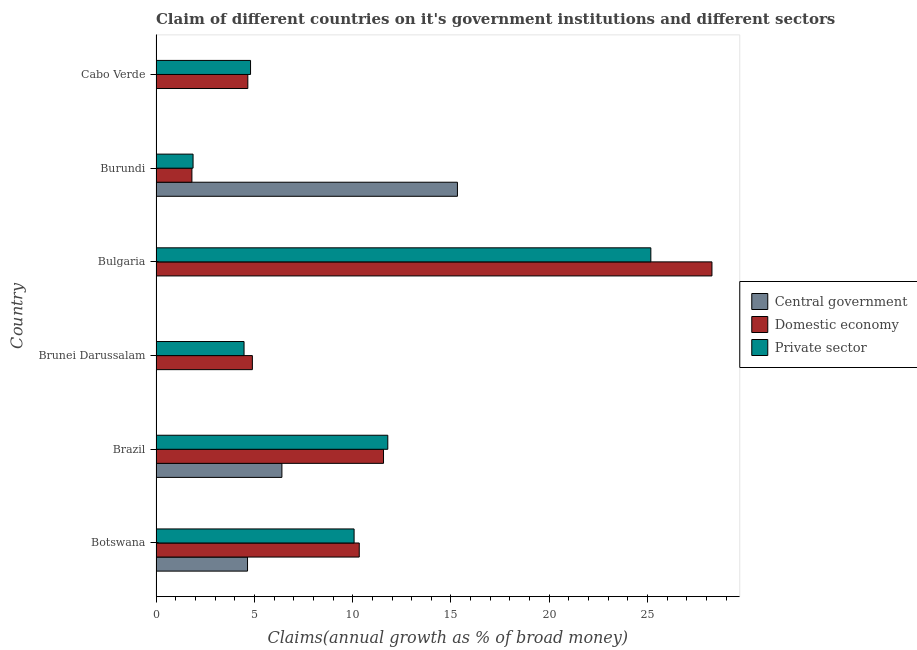Are the number of bars per tick equal to the number of legend labels?
Your answer should be compact. No. Are the number of bars on each tick of the Y-axis equal?
Give a very brief answer. No. How many bars are there on the 3rd tick from the bottom?
Offer a very short reply. 2. What is the label of the 2nd group of bars from the top?
Provide a succinct answer. Burundi. Across all countries, what is the maximum percentage of claim on the private sector?
Give a very brief answer. 25.16. Across all countries, what is the minimum percentage of claim on the private sector?
Your answer should be very brief. 1.88. In which country was the percentage of claim on the central government maximum?
Ensure brevity in your answer.  Burundi. What is the total percentage of claim on the central government in the graph?
Provide a succinct answer. 26.38. What is the difference between the percentage of claim on the domestic economy in Brunei Darussalam and that in Bulgaria?
Provide a short and direct response. -23.37. What is the difference between the percentage of claim on the private sector in Bulgaria and the percentage of claim on the central government in Cabo Verde?
Offer a very short reply. 25.16. What is the average percentage of claim on the central government per country?
Ensure brevity in your answer.  4.4. What is the difference between the percentage of claim on the domestic economy and percentage of claim on the private sector in Brazil?
Your answer should be compact. -0.22. What is the ratio of the percentage of claim on the domestic economy in Botswana to that in Cabo Verde?
Your response must be concise. 2.21. What is the difference between the highest and the second highest percentage of claim on the domestic economy?
Your answer should be compact. 16.7. What is the difference between the highest and the lowest percentage of claim on the private sector?
Keep it short and to the point. 23.28. In how many countries, is the percentage of claim on the private sector greater than the average percentage of claim on the private sector taken over all countries?
Offer a terse response. 3. Is the sum of the percentage of claim on the central government in Botswana and Burundi greater than the maximum percentage of claim on the domestic economy across all countries?
Keep it short and to the point. No. Are all the bars in the graph horizontal?
Make the answer very short. Yes. Are the values on the major ticks of X-axis written in scientific E-notation?
Your answer should be compact. No. Does the graph contain grids?
Offer a terse response. No. What is the title of the graph?
Keep it short and to the point. Claim of different countries on it's government institutions and different sectors. Does "Transport equipments" appear as one of the legend labels in the graph?
Your response must be concise. No. What is the label or title of the X-axis?
Give a very brief answer. Claims(annual growth as % of broad money). What is the label or title of the Y-axis?
Offer a terse response. Country. What is the Claims(annual growth as % of broad money) in Central government in Botswana?
Your response must be concise. 4.65. What is the Claims(annual growth as % of broad money) of Domestic economy in Botswana?
Your response must be concise. 10.33. What is the Claims(annual growth as % of broad money) in Private sector in Botswana?
Your answer should be compact. 10.07. What is the Claims(annual growth as % of broad money) of Central government in Brazil?
Offer a terse response. 6.4. What is the Claims(annual growth as % of broad money) in Domestic economy in Brazil?
Your answer should be compact. 11.57. What is the Claims(annual growth as % of broad money) in Private sector in Brazil?
Provide a succinct answer. 11.79. What is the Claims(annual growth as % of broad money) in Domestic economy in Brunei Darussalam?
Keep it short and to the point. 4.9. What is the Claims(annual growth as % of broad money) in Private sector in Brunei Darussalam?
Your answer should be very brief. 4.48. What is the Claims(annual growth as % of broad money) of Domestic economy in Bulgaria?
Offer a very short reply. 28.27. What is the Claims(annual growth as % of broad money) of Private sector in Bulgaria?
Offer a very short reply. 25.16. What is the Claims(annual growth as % of broad money) of Central government in Burundi?
Your answer should be compact. 15.33. What is the Claims(annual growth as % of broad money) in Domestic economy in Burundi?
Ensure brevity in your answer.  1.83. What is the Claims(annual growth as % of broad money) of Private sector in Burundi?
Provide a short and direct response. 1.88. What is the Claims(annual growth as % of broad money) of Domestic economy in Cabo Verde?
Your answer should be very brief. 4.67. What is the Claims(annual growth as % of broad money) in Private sector in Cabo Verde?
Keep it short and to the point. 4.81. Across all countries, what is the maximum Claims(annual growth as % of broad money) in Central government?
Provide a short and direct response. 15.33. Across all countries, what is the maximum Claims(annual growth as % of broad money) in Domestic economy?
Provide a succinct answer. 28.27. Across all countries, what is the maximum Claims(annual growth as % of broad money) in Private sector?
Ensure brevity in your answer.  25.16. Across all countries, what is the minimum Claims(annual growth as % of broad money) of Central government?
Make the answer very short. 0. Across all countries, what is the minimum Claims(annual growth as % of broad money) of Domestic economy?
Keep it short and to the point. 1.83. Across all countries, what is the minimum Claims(annual growth as % of broad money) of Private sector?
Provide a short and direct response. 1.88. What is the total Claims(annual growth as % of broad money) of Central government in the graph?
Ensure brevity in your answer.  26.38. What is the total Claims(annual growth as % of broad money) in Domestic economy in the graph?
Make the answer very short. 61.57. What is the total Claims(annual growth as % of broad money) in Private sector in the graph?
Your answer should be very brief. 58.19. What is the difference between the Claims(annual growth as % of broad money) of Central government in Botswana and that in Brazil?
Your response must be concise. -1.75. What is the difference between the Claims(annual growth as % of broad money) in Domestic economy in Botswana and that in Brazil?
Make the answer very short. -1.23. What is the difference between the Claims(annual growth as % of broad money) in Private sector in Botswana and that in Brazil?
Your answer should be very brief. -1.71. What is the difference between the Claims(annual growth as % of broad money) of Domestic economy in Botswana and that in Brunei Darussalam?
Offer a terse response. 5.43. What is the difference between the Claims(annual growth as % of broad money) of Private sector in Botswana and that in Brunei Darussalam?
Your answer should be compact. 5.6. What is the difference between the Claims(annual growth as % of broad money) in Domestic economy in Botswana and that in Bulgaria?
Offer a terse response. -17.94. What is the difference between the Claims(annual growth as % of broad money) of Private sector in Botswana and that in Bulgaria?
Provide a succinct answer. -15.09. What is the difference between the Claims(annual growth as % of broad money) of Central government in Botswana and that in Burundi?
Your answer should be very brief. -10.67. What is the difference between the Claims(annual growth as % of broad money) in Domestic economy in Botswana and that in Burundi?
Provide a succinct answer. 8.51. What is the difference between the Claims(annual growth as % of broad money) of Private sector in Botswana and that in Burundi?
Your answer should be compact. 8.19. What is the difference between the Claims(annual growth as % of broad money) in Domestic economy in Botswana and that in Cabo Verde?
Offer a very short reply. 5.67. What is the difference between the Claims(annual growth as % of broad money) in Private sector in Botswana and that in Cabo Verde?
Ensure brevity in your answer.  5.27. What is the difference between the Claims(annual growth as % of broad money) of Domestic economy in Brazil and that in Brunei Darussalam?
Provide a short and direct response. 6.67. What is the difference between the Claims(annual growth as % of broad money) of Private sector in Brazil and that in Brunei Darussalam?
Your answer should be compact. 7.31. What is the difference between the Claims(annual growth as % of broad money) in Domestic economy in Brazil and that in Bulgaria?
Provide a short and direct response. -16.7. What is the difference between the Claims(annual growth as % of broad money) in Private sector in Brazil and that in Bulgaria?
Ensure brevity in your answer.  -13.38. What is the difference between the Claims(annual growth as % of broad money) of Central government in Brazil and that in Burundi?
Your answer should be compact. -8.93. What is the difference between the Claims(annual growth as % of broad money) of Domestic economy in Brazil and that in Burundi?
Your answer should be very brief. 9.74. What is the difference between the Claims(annual growth as % of broad money) of Private sector in Brazil and that in Burundi?
Make the answer very short. 9.9. What is the difference between the Claims(annual growth as % of broad money) of Private sector in Brazil and that in Cabo Verde?
Your answer should be very brief. 6.98. What is the difference between the Claims(annual growth as % of broad money) of Domestic economy in Brunei Darussalam and that in Bulgaria?
Give a very brief answer. -23.37. What is the difference between the Claims(annual growth as % of broad money) in Private sector in Brunei Darussalam and that in Bulgaria?
Your answer should be compact. -20.69. What is the difference between the Claims(annual growth as % of broad money) in Domestic economy in Brunei Darussalam and that in Burundi?
Your response must be concise. 3.07. What is the difference between the Claims(annual growth as % of broad money) of Private sector in Brunei Darussalam and that in Burundi?
Your answer should be compact. 2.59. What is the difference between the Claims(annual growth as % of broad money) in Domestic economy in Brunei Darussalam and that in Cabo Verde?
Provide a succinct answer. 0.23. What is the difference between the Claims(annual growth as % of broad money) in Private sector in Brunei Darussalam and that in Cabo Verde?
Provide a short and direct response. -0.33. What is the difference between the Claims(annual growth as % of broad money) in Domestic economy in Bulgaria and that in Burundi?
Provide a short and direct response. 26.45. What is the difference between the Claims(annual growth as % of broad money) of Private sector in Bulgaria and that in Burundi?
Provide a short and direct response. 23.28. What is the difference between the Claims(annual growth as % of broad money) of Domestic economy in Bulgaria and that in Cabo Verde?
Offer a very short reply. 23.6. What is the difference between the Claims(annual growth as % of broad money) of Private sector in Bulgaria and that in Cabo Verde?
Your answer should be compact. 20.36. What is the difference between the Claims(annual growth as % of broad money) in Domestic economy in Burundi and that in Cabo Verde?
Keep it short and to the point. -2.84. What is the difference between the Claims(annual growth as % of broad money) in Private sector in Burundi and that in Cabo Verde?
Make the answer very short. -2.92. What is the difference between the Claims(annual growth as % of broad money) of Central government in Botswana and the Claims(annual growth as % of broad money) of Domestic economy in Brazil?
Your response must be concise. -6.92. What is the difference between the Claims(annual growth as % of broad money) in Central government in Botswana and the Claims(annual growth as % of broad money) in Private sector in Brazil?
Offer a very short reply. -7.13. What is the difference between the Claims(annual growth as % of broad money) of Domestic economy in Botswana and the Claims(annual growth as % of broad money) of Private sector in Brazil?
Your response must be concise. -1.45. What is the difference between the Claims(annual growth as % of broad money) of Central government in Botswana and the Claims(annual growth as % of broad money) of Domestic economy in Brunei Darussalam?
Keep it short and to the point. -0.25. What is the difference between the Claims(annual growth as % of broad money) in Central government in Botswana and the Claims(annual growth as % of broad money) in Private sector in Brunei Darussalam?
Your answer should be compact. 0.18. What is the difference between the Claims(annual growth as % of broad money) in Domestic economy in Botswana and the Claims(annual growth as % of broad money) in Private sector in Brunei Darussalam?
Make the answer very short. 5.86. What is the difference between the Claims(annual growth as % of broad money) of Central government in Botswana and the Claims(annual growth as % of broad money) of Domestic economy in Bulgaria?
Your answer should be very brief. -23.62. What is the difference between the Claims(annual growth as % of broad money) of Central government in Botswana and the Claims(annual growth as % of broad money) of Private sector in Bulgaria?
Your answer should be compact. -20.51. What is the difference between the Claims(annual growth as % of broad money) in Domestic economy in Botswana and the Claims(annual growth as % of broad money) in Private sector in Bulgaria?
Give a very brief answer. -14.83. What is the difference between the Claims(annual growth as % of broad money) of Central government in Botswana and the Claims(annual growth as % of broad money) of Domestic economy in Burundi?
Offer a terse response. 2.83. What is the difference between the Claims(annual growth as % of broad money) in Central government in Botswana and the Claims(annual growth as % of broad money) in Private sector in Burundi?
Give a very brief answer. 2.77. What is the difference between the Claims(annual growth as % of broad money) of Domestic economy in Botswana and the Claims(annual growth as % of broad money) of Private sector in Burundi?
Provide a short and direct response. 8.45. What is the difference between the Claims(annual growth as % of broad money) of Central government in Botswana and the Claims(annual growth as % of broad money) of Domestic economy in Cabo Verde?
Provide a succinct answer. -0.02. What is the difference between the Claims(annual growth as % of broad money) in Central government in Botswana and the Claims(annual growth as % of broad money) in Private sector in Cabo Verde?
Offer a terse response. -0.15. What is the difference between the Claims(annual growth as % of broad money) in Domestic economy in Botswana and the Claims(annual growth as % of broad money) in Private sector in Cabo Verde?
Provide a succinct answer. 5.53. What is the difference between the Claims(annual growth as % of broad money) of Central government in Brazil and the Claims(annual growth as % of broad money) of Domestic economy in Brunei Darussalam?
Ensure brevity in your answer.  1.5. What is the difference between the Claims(annual growth as % of broad money) of Central government in Brazil and the Claims(annual growth as % of broad money) of Private sector in Brunei Darussalam?
Provide a short and direct response. 1.93. What is the difference between the Claims(annual growth as % of broad money) of Domestic economy in Brazil and the Claims(annual growth as % of broad money) of Private sector in Brunei Darussalam?
Your response must be concise. 7.09. What is the difference between the Claims(annual growth as % of broad money) in Central government in Brazil and the Claims(annual growth as % of broad money) in Domestic economy in Bulgaria?
Provide a succinct answer. -21.87. What is the difference between the Claims(annual growth as % of broad money) of Central government in Brazil and the Claims(annual growth as % of broad money) of Private sector in Bulgaria?
Your response must be concise. -18.76. What is the difference between the Claims(annual growth as % of broad money) of Domestic economy in Brazil and the Claims(annual growth as % of broad money) of Private sector in Bulgaria?
Make the answer very short. -13.59. What is the difference between the Claims(annual growth as % of broad money) of Central government in Brazil and the Claims(annual growth as % of broad money) of Domestic economy in Burundi?
Offer a terse response. 4.58. What is the difference between the Claims(annual growth as % of broad money) of Central government in Brazil and the Claims(annual growth as % of broad money) of Private sector in Burundi?
Provide a short and direct response. 4.52. What is the difference between the Claims(annual growth as % of broad money) of Domestic economy in Brazil and the Claims(annual growth as % of broad money) of Private sector in Burundi?
Your response must be concise. 9.69. What is the difference between the Claims(annual growth as % of broad money) in Central government in Brazil and the Claims(annual growth as % of broad money) in Domestic economy in Cabo Verde?
Offer a very short reply. 1.73. What is the difference between the Claims(annual growth as % of broad money) of Central government in Brazil and the Claims(annual growth as % of broad money) of Private sector in Cabo Verde?
Keep it short and to the point. 1.59. What is the difference between the Claims(annual growth as % of broad money) in Domestic economy in Brazil and the Claims(annual growth as % of broad money) in Private sector in Cabo Verde?
Provide a succinct answer. 6.76. What is the difference between the Claims(annual growth as % of broad money) of Domestic economy in Brunei Darussalam and the Claims(annual growth as % of broad money) of Private sector in Bulgaria?
Ensure brevity in your answer.  -20.26. What is the difference between the Claims(annual growth as % of broad money) in Domestic economy in Brunei Darussalam and the Claims(annual growth as % of broad money) in Private sector in Burundi?
Offer a terse response. 3.02. What is the difference between the Claims(annual growth as % of broad money) in Domestic economy in Brunei Darussalam and the Claims(annual growth as % of broad money) in Private sector in Cabo Verde?
Offer a very short reply. 0.09. What is the difference between the Claims(annual growth as % of broad money) of Domestic economy in Bulgaria and the Claims(annual growth as % of broad money) of Private sector in Burundi?
Provide a short and direct response. 26.39. What is the difference between the Claims(annual growth as % of broad money) in Domestic economy in Bulgaria and the Claims(annual growth as % of broad money) in Private sector in Cabo Verde?
Your response must be concise. 23.46. What is the difference between the Claims(annual growth as % of broad money) in Central government in Burundi and the Claims(annual growth as % of broad money) in Domestic economy in Cabo Verde?
Offer a terse response. 10.66. What is the difference between the Claims(annual growth as % of broad money) of Central government in Burundi and the Claims(annual growth as % of broad money) of Private sector in Cabo Verde?
Offer a very short reply. 10.52. What is the difference between the Claims(annual growth as % of broad money) in Domestic economy in Burundi and the Claims(annual growth as % of broad money) in Private sector in Cabo Verde?
Make the answer very short. -2.98. What is the average Claims(annual growth as % of broad money) of Central government per country?
Your response must be concise. 4.4. What is the average Claims(annual growth as % of broad money) of Domestic economy per country?
Offer a very short reply. 10.26. What is the average Claims(annual growth as % of broad money) in Private sector per country?
Make the answer very short. 9.7. What is the difference between the Claims(annual growth as % of broad money) in Central government and Claims(annual growth as % of broad money) in Domestic economy in Botswana?
Ensure brevity in your answer.  -5.68. What is the difference between the Claims(annual growth as % of broad money) of Central government and Claims(annual growth as % of broad money) of Private sector in Botswana?
Offer a terse response. -5.42. What is the difference between the Claims(annual growth as % of broad money) of Domestic economy and Claims(annual growth as % of broad money) of Private sector in Botswana?
Your answer should be very brief. 0.26. What is the difference between the Claims(annual growth as % of broad money) in Central government and Claims(annual growth as % of broad money) in Domestic economy in Brazil?
Your answer should be compact. -5.17. What is the difference between the Claims(annual growth as % of broad money) of Central government and Claims(annual growth as % of broad money) of Private sector in Brazil?
Offer a very short reply. -5.38. What is the difference between the Claims(annual growth as % of broad money) in Domestic economy and Claims(annual growth as % of broad money) in Private sector in Brazil?
Provide a succinct answer. -0.22. What is the difference between the Claims(annual growth as % of broad money) in Domestic economy and Claims(annual growth as % of broad money) in Private sector in Brunei Darussalam?
Offer a terse response. 0.42. What is the difference between the Claims(annual growth as % of broad money) in Domestic economy and Claims(annual growth as % of broad money) in Private sector in Bulgaria?
Your answer should be very brief. 3.11. What is the difference between the Claims(annual growth as % of broad money) of Central government and Claims(annual growth as % of broad money) of Domestic economy in Burundi?
Your answer should be compact. 13.5. What is the difference between the Claims(annual growth as % of broad money) of Central government and Claims(annual growth as % of broad money) of Private sector in Burundi?
Provide a succinct answer. 13.44. What is the difference between the Claims(annual growth as % of broad money) of Domestic economy and Claims(annual growth as % of broad money) of Private sector in Burundi?
Keep it short and to the point. -0.06. What is the difference between the Claims(annual growth as % of broad money) of Domestic economy and Claims(annual growth as % of broad money) of Private sector in Cabo Verde?
Offer a terse response. -0.14. What is the ratio of the Claims(annual growth as % of broad money) in Central government in Botswana to that in Brazil?
Provide a succinct answer. 0.73. What is the ratio of the Claims(annual growth as % of broad money) of Domestic economy in Botswana to that in Brazil?
Give a very brief answer. 0.89. What is the ratio of the Claims(annual growth as % of broad money) of Private sector in Botswana to that in Brazil?
Provide a short and direct response. 0.85. What is the ratio of the Claims(annual growth as % of broad money) in Domestic economy in Botswana to that in Brunei Darussalam?
Provide a succinct answer. 2.11. What is the ratio of the Claims(annual growth as % of broad money) of Private sector in Botswana to that in Brunei Darussalam?
Ensure brevity in your answer.  2.25. What is the ratio of the Claims(annual growth as % of broad money) of Domestic economy in Botswana to that in Bulgaria?
Provide a succinct answer. 0.37. What is the ratio of the Claims(annual growth as % of broad money) in Private sector in Botswana to that in Bulgaria?
Offer a terse response. 0.4. What is the ratio of the Claims(annual growth as % of broad money) in Central government in Botswana to that in Burundi?
Give a very brief answer. 0.3. What is the ratio of the Claims(annual growth as % of broad money) in Domestic economy in Botswana to that in Burundi?
Your response must be concise. 5.66. What is the ratio of the Claims(annual growth as % of broad money) in Private sector in Botswana to that in Burundi?
Your response must be concise. 5.35. What is the ratio of the Claims(annual growth as % of broad money) of Domestic economy in Botswana to that in Cabo Verde?
Make the answer very short. 2.21. What is the ratio of the Claims(annual growth as % of broad money) of Private sector in Botswana to that in Cabo Verde?
Make the answer very short. 2.1. What is the ratio of the Claims(annual growth as % of broad money) of Domestic economy in Brazil to that in Brunei Darussalam?
Offer a terse response. 2.36. What is the ratio of the Claims(annual growth as % of broad money) of Private sector in Brazil to that in Brunei Darussalam?
Offer a terse response. 2.63. What is the ratio of the Claims(annual growth as % of broad money) of Domestic economy in Brazil to that in Bulgaria?
Your response must be concise. 0.41. What is the ratio of the Claims(annual growth as % of broad money) in Private sector in Brazil to that in Bulgaria?
Give a very brief answer. 0.47. What is the ratio of the Claims(annual growth as % of broad money) in Central government in Brazil to that in Burundi?
Make the answer very short. 0.42. What is the ratio of the Claims(annual growth as % of broad money) of Domestic economy in Brazil to that in Burundi?
Your response must be concise. 6.34. What is the ratio of the Claims(annual growth as % of broad money) in Private sector in Brazil to that in Burundi?
Ensure brevity in your answer.  6.26. What is the ratio of the Claims(annual growth as % of broad money) of Domestic economy in Brazil to that in Cabo Verde?
Provide a succinct answer. 2.48. What is the ratio of the Claims(annual growth as % of broad money) of Private sector in Brazil to that in Cabo Verde?
Offer a very short reply. 2.45. What is the ratio of the Claims(annual growth as % of broad money) in Domestic economy in Brunei Darussalam to that in Bulgaria?
Provide a succinct answer. 0.17. What is the ratio of the Claims(annual growth as % of broad money) of Private sector in Brunei Darussalam to that in Bulgaria?
Keep it short and to the point. 0.18. What is the ratio of the Claims(annual growth as % of broad money) of Domestic economy in Brunei Darussalam to that in Burundi?
Ensure brevity in your answer.  2.68. What is the ratio of the Claims(annual growth as % of broad money) in Private sector in Brunei Darussalam to that in Burundi?
Offer a very short reply. 2.38. What is the ratio of the Claims(annual growth as % of broad money) of Domestic economy in Brunei Darussalam to that in Cabo Verde?
Your response must be concise. 1.05. What is the ratio of the Claims(annual growth as % of broad money) of Private sector in Brunei Darussalam to that in Cabo Verde?
Offer a terse response. 0.93. What is the ratio of the Claims(annual growth as % of broad money) in Domestic economy in Bulgaria to that in Burundi?
Make the answer very short. 15.49. What is the ratio of the Claims(annual growth as % of broad money) of Private sector in Bulgaria to that in Burundi?
Offer a very short reply. 13.36. What is the ratio of the Claims(annual growth as % of broad money) in Domestic economy in Bulgaria to that in Cabo Verde?
Offer a very short reply. 6.06. What is the ratio of the Claims(annual growth as % of broad money) of Private sector in Bulgaria to that in Cabo Verde?
Your answer should be very brief. 5.24. What is the ratio of the Claims(annual growth as % of broad money) in Domestic economy in Burundi to that in Cabo Verde?
Keep it short and to the point. 0.39. What is the ratio of the Claims(annual growth as % of broad money) in Private sector in Burundi to that in Cabo Verde?
Provide a short and direct response. 0.39. What is the difference between the highest and the second highest Claims(annual growth as % of broad money) in Central government?
Your answer should be compact. 8.93. What is the difference between the highest and the second highest Claims(annual growth as % of broad money) in Domestic economy?
Offer a very short reply. 16.7. What is the difference between the highest and the second highest Claims(annual growth as % of broad money) in Private sector?
Your answer should be compact. 13.38. What is the difference between the highest and the lowest Claims(annual growth as % of broad money) of Central government?
Your response must be concise. 15.33. What is the difference between the highest and the lowest Claims(annual growth as % of broad money) in Domestic economy?
Your answer should be compact. 26.45. What is the difference between the highest and the lowest Claims(annual growth as % of broad money) of Private sector?
Your answer should be compact. 23.28. 